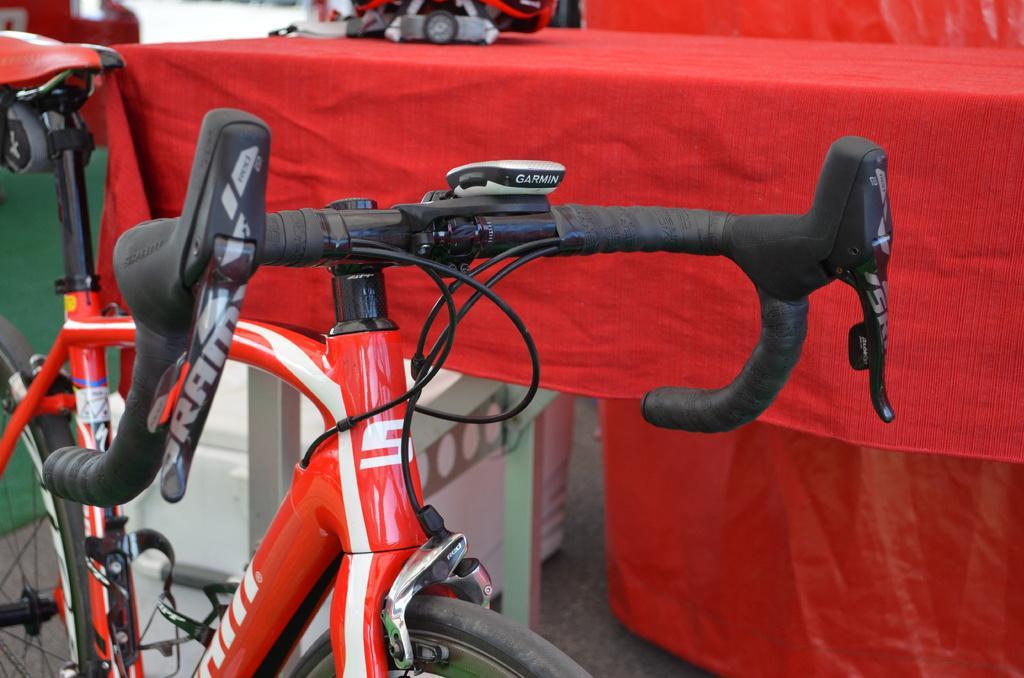Describe this image in one or two sentences. Here in this picture we can see a red colored bicycle present on the ground over there and beside it we can see table which is covered with red colored cloth on it over there. 